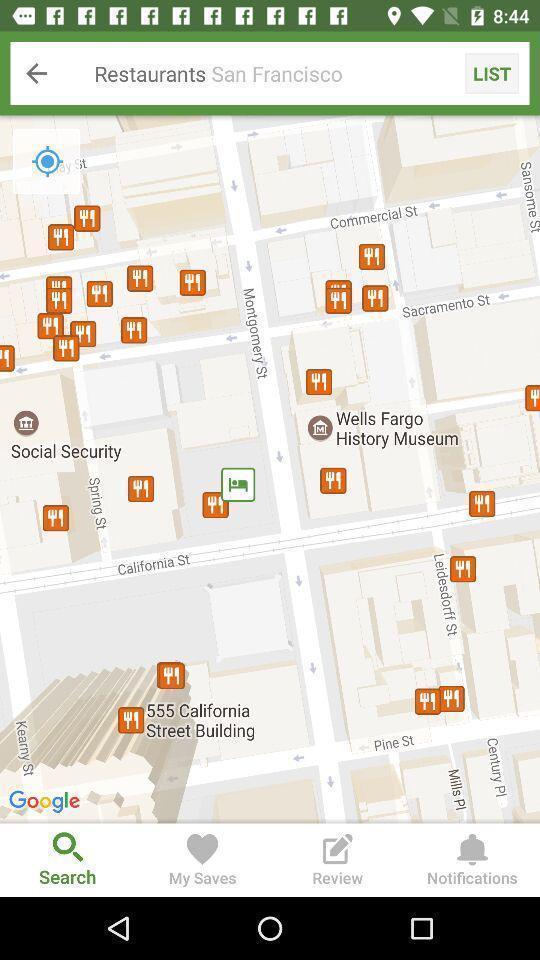What details can you identify in this image? Search page to find location of restaurants. 